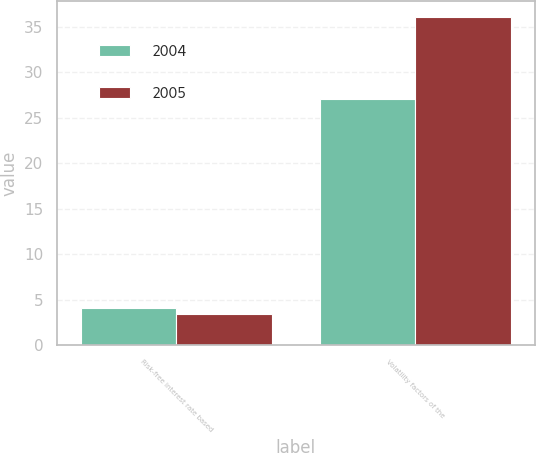Convert chart to OTSL. <chart><loc_0><loc_0><loc_500><loc_500><stacked_bar_chart><ecel><fcel>Risk-free interest rate based<fcel>Volatility factors of the<nl><fcel>2004<fcel>4.11<fcel>27<nl><fcel>2005<fcel>3.42<fcel>36<nl></chart> 